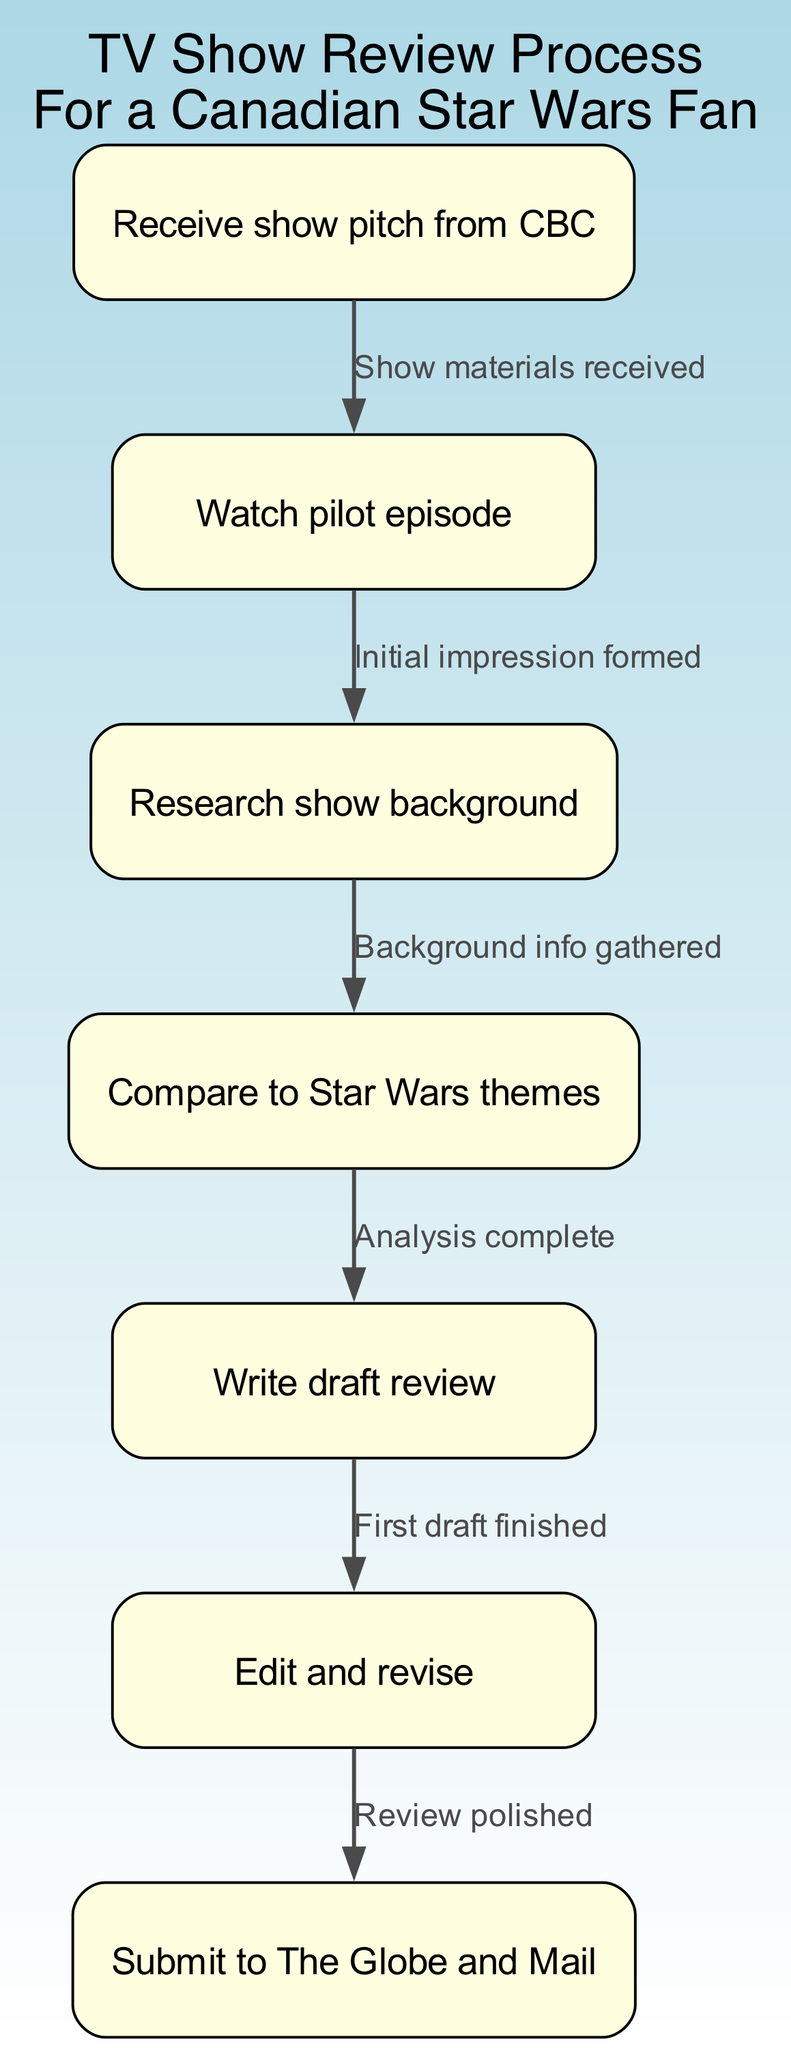What is the first step in the review process? The first node in the diagram represents the initial action taken, which is to "Receive show pitch from CBC." This is clearly the starting point of the flowchart.
Answer: Receive show pitch from CBC How many nodes are there in the diagram? By counting each distinct action represented as a node in the flowchart, we find a total of seven nodes: Receive show pitch from CBC, Watch pilot episode, Research show background, Compare to Star Wars themes, Write draft review, Edit and revise, Submit to The Globe and Mail.
Answer: Seven What does the edge from "Watch pilot episode" to "Research show background" represent? The edge indicates the transition from watching the pilot episode to gathering background information, summarized by the text "Initial impression formed," which describes the purpose of this transition.
Answer: Initial impression formed Which step follows "Edit and revise"? The diagram clearly shows that the step that comes after "Edit and revise" is "Submit to The Globe and Mail." This is depicted as the next node linked by an edge.
Answer: Submit to The Globe and Mail What is the relationship between "Compare to Star Wars themes" and "Write draft review"? The edge connecting "Compare to Star Wars themes" and "Write draft review" indicates that after completing the analysis of the show's alignment with Star Wars, the next step is to write the draft review. The text on the edge states, "Analysis complete."
Answer: Analysis complete What is the last action taken in the review process? By analyzing the flowchart, we see that the final action, or the last node in the process, is "Submit to The Globe and Mail," which indicates the culmination of all prior actions in the review process.
Answer: Submit to The Globe and Mail Which step involves gathering background information about the show? In the flowchart, the step dedicated to gathering background information is labeled "Research show background," which follows the action of watching the pilot episode.
Answer: Research show background How does the review process relate to Star Wars themes? The review process includes a dedicated step labeled "Compare to Star Wars themes," indicating a specific analysis focus to see how the show aligns with these iconic elements. This step is positioned in the flow after the background research.
Answer: Compare to Star Wars themes 